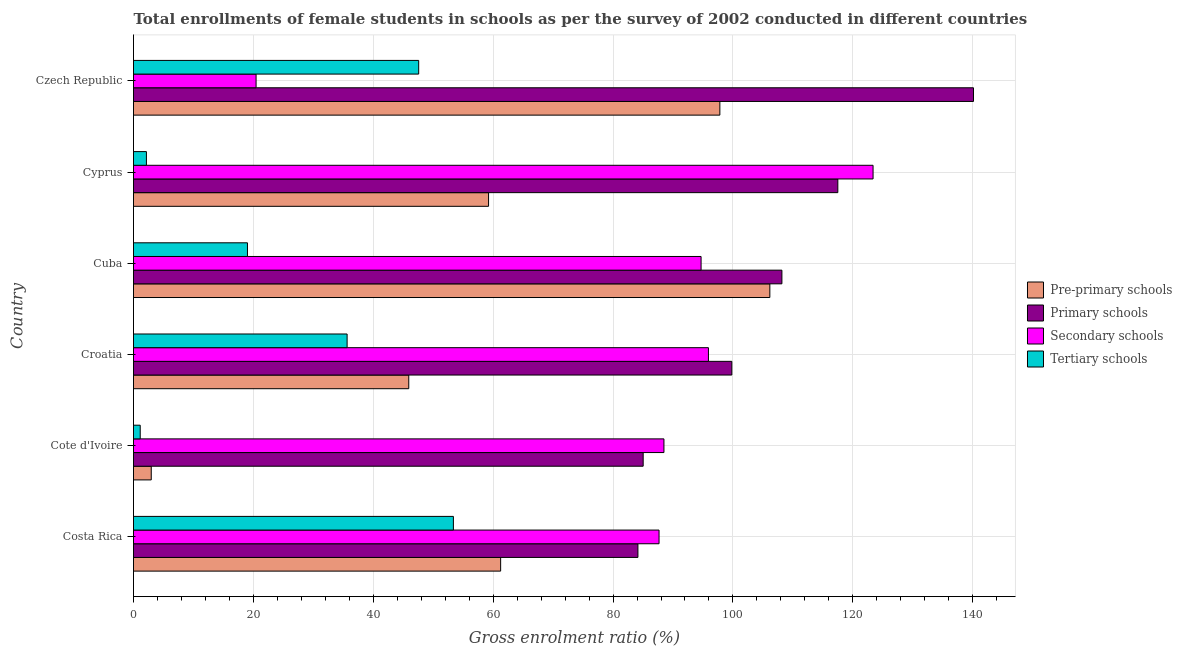How many different coloured bars are there?
Ensure brevity in your answer.  4. How many groups of bars are there?
Offer a very short reply. 6. Are the number of bars per tick equal to the number of legend labels?
Provide a succinct answer. Yes. In how many cases, is the number of bars for a given country not equal to the number of legend labels?
Your answer should be compact. 0. What is the gross enrolment ratio(female) in secondary schools in Croatia?
Give a very brief answer. 95.91. Across all countries, what is the maximum gross enrolment ratio(female) in primary schools?
Keep it short and to the point. 140.13. Across all countries, what is the minimum gross enrolment ratio(female) in secondary schools?
Ensure brevity in your answer.  20.45. In which country was the gross enrolment ratio(female) in pre-primary schools maximum?
Offer a terse response. Cuba. In which country was the gross enrolment ratio(female) in tertiary schools minimum?
Give a very brief answer. Cote d'Ivoire. What is the total gross enrolment ratio(female) in secondary schools in the graph?
Your response must be concise. 510.58. What is the difference between the gross enrolment ratio(female) in secondary schools in Croatia and that in Cyprus?
Give a very brief answer. -27.46. What is the difference between the gross enrolment ratio(female) in primary schools in Czech Republic and the gross enrolment ratio(female) in tertiary schools in Cote d'Ivoire?
Offer a terse response. 139.01. What is the average gross enrolment ratio(female) in secondary schools per country?
Make the answer very short. 85.1. What is the difference between the gross enrolment ratio(female) in primary schools and gross enrolment ratio(female) in secondary schools in Croatia?
Your answer should be very brief. 3.9. What is the ratio of the gross enrolment ratio(female) in primary schools in Costa Rica to that in Cuba?
Give a very brief answer. 0.78. Is the gross enrolment ratio(female) in secondary schools in Cote d'Ivoire less than that in Czech Republic?
Make the answer very short. No. Is the difference between the gross enrolment ratio(female) in primary schools in Cuba and Cyprus greater than the difference between the gross enrolment ratio(female) in tertiary schools in Cuba and Cyprus?
Give a very brief answer. No. What is the difference between the highest and the second highest gross enrolment ratio(female) in pre-primary schools?
Your answer should be compact. 8.34. What is the difference between the highest and the lowest gross enrolment ratio(female) in pre-primary schools?
Make the answer very short. 103.19. Is the sum of the gross enrolment ratio(female) in pre-primary schools in Costa Rica and Czech Republic greater than the maximum gross enrolment ratio(female) in primary schools across all countries?
Offer a very short reply. Yes. What does the 2nd bar from the top in Cote d'Ivoire represents?
Ensure brevity in your answer.  Secondary schools. What does the 3rd bar from the bottom in Croatia represents?
Provide a succinct answer. Secondary schools. Is it the case that in every country, the sum of the gross enrolment ratio(female) in pre-primary schools and gross enrolment ratio(female) in primary schools is greater than the gross enrolment ratio(female) in secondary schools?
Offer a very short reply. No. How many bars are there?
Give a very brief answer. 24. Are all the bars in the graph horizontal?
Your answer should be compact. Yes. How many countries are there in the graph?
Your answer should be very brief. 6. Are the values on the major ticks of X-axis written in scientific E-notation?
Offer a terse response. No. Does the graph contain grids?
Ensure brevity in your answer.  Yes. How are the legend labels stacked?
Provide a short and direct response. Vertical. What is the title of the graph?
Give a very brief answer. Total enrollments of female students in schools as per the survey of 2002 conducted in different countries. What is the Gross enrolment ratio (%) in Pre-primary schools in Costa Rica?
Make the answer very short. 61.25. What is the Gross enrolment ratio (%) of Primary schools in Costa Rica?
Keep it short and to the point. 84.15. What is the Gross enrolment ratio (%) of Secondary schools in Costa Rica?
Offer a terse response. 87.67. What is the Gross enrolment ratio (%) in Tertiary schools in Costa Rica?
Ensure brevity in your answer.  53.36. What is the Gross enrolment ratio (%) of Pre-primary schools in Cote d'Ivoire?
Your answer should be very brief. 2.96. What is the Gross enrolment ratio (%) of Primary schools in Cote d'Ivoire?
Make the answer very short. 85.03. What is the Gross enrolment ratio (%) in Secondary schools in Cote d'Ivoire?
Ensure brevity in your answer.  88.49. What is the Gross enrolment ratio (%) of Tertiary schools in Cote d'Ivoire?
Your response must be concise. 1.12. What is the Gross enrolment ratio (%) of Pre-primary schools in Croatia?
Your answer should be compact. 45.92. What is the Gross enrolment ratio (%) in Primary schools in Croatia?
Provide a short and direct response. 99.81. What is the Gross enrolment ratio (%) in Secondary schools in Croatia?
Offer a terse response. 95.91. What is the Gross enrolment ratio (%) in Tertiary schools in Croatia?
Your answer should be compact. 35.63. What is the Gross enrolment ratio (%) of Pre-primary schools in Cuba?
Your response must be concise. 106.15. What is the Gross enrolment ratio (%) in Primary schools in Cuba?
Give a very brief answer. 108.17. What is the Gross enrolment ratio (%) of Secondary schools in Cuba?
Keep it short and to the point. 94.68. What is the Gross enrolment ratio (%) in Tertiary schools in Cuba?
Your answer should be very brief. 19.01. What is the Gross enrolment ratio (%) in Pre-primary schools in Cyprus?
Offer a very short reply. 59.23. What is the Gross enrolment ratio (%) in Primary schools in Cyprus?
Ensure brevity in your answer.  117.5. What is the Gross enrolment ratio (%) in Secondary schools in Cyprus?
Provide a succinct answer. 123.38. What is the Gross enrolment ratio (%) of Tertiary schools in Cyprus?
Your answer should be compact. 2.16. What is the Gross enrolment ratio (%) of Pre-primary schools in Czech Republic?
Your response must be concise. 97.82. What is the Gross enrolment ratio (%) of Primary schools in Czech Republic?
Your response must be concise. 140.13. What is the Gross enrolment ratio (%) in Secondary schools in Czech Republic?
Your answer should be very brief. 20.45. What is the Gross enrolment ratio (%) of Tertiary schools in Czech Republic?
Keep it short and to the point. 47.57. Across all countries, what is the maximum Gross enrolment ratio (%) in Pre-primary schools?
Keep it short and to the point. 106.15. Across all countries, what is the maximum Gross enrolment ratio (%) in Primary schools?
Your response must be concise. 140.13. Across all countries, what is the maximum Gross enrolment ratio (%) of Secondary schools?
Your answer should be compact. 123.38. Across all countries, what is the maximum Gross enrolment ratio (%) of Tertiary schools?
Your answer should be very brief. 53.36. Across all countries, what is the minimum Gross enrolment ratio (%) in Pre-primary schools?
Offer a very short reply. 2.96. Across all countries, what is the minimum Gross enrolment ratio (%) in Primary schools?
Offer a terse response. 84.15. Across all countries, what is the minimum Gross enrolment ratio (%) in Secondary schools?
Give a very brief answer. 20.45. Across all countries, what is the minimum Gross enrolment ratio (%) in Tertiary schools?
Give a very brief answer. 1.12. What is the total Gross enrolment ratio (%) of Pre-primary schools in the graph?
Your answer should be compact. 373.33. What is the total Gross enrolment ratio (%) in Primary schools in the graph?
Your answer should be very brief. 634.78. What is the total Gross enrolment ratio (%) in Secondary schools in the graph?
Offer a very short reply. 510.58. What is the total Gross enrolment ratio (%) of Tertiary schools in the graph?
Your answer should be compact. 158.86. What is the difference between the Gross enrolment ratio (%) in Pre-primary schools in Costa Rica and that in Cote d'Ivoire?
Give a very brief answer. 58.29. What is the difference between the Gross enrolment ratio (%) in Primary schools in Costa Rica and that in Cote d'Ivoire?
Your answer should be very brief. -0.88. What is the difference between the Gross enrolment ratio (%) in Secondary schools in Costa Rica and that in Cote d'Ivoire?
Provide a short and direct response. -0.82. What is the difference between the Gross enrolment ratio (%) in Tertiary schools in Costa Rica and that in Cote d'Ivoire?
Ensure brevity in your answer.  52.24. What is the difference between the Gross enrolment ratio (%) in Pre-primary schools in Costa Rica and that in Croatia?
Your response must be concise. 15.33. What is the difference between the Gross enrolment ratio (%) of Primary schools in Costa Rica and that in Croatia?
Your response must be concise. -15.67. What is the difference between the Gross enrolment ratio (%) in Secondary schools in Costa Rica and that in Croatia?
Your response must be concise. -8.24. What is the difference between the Gross enrolment ratio (%) of Tertiary schools in Costa Rica and that in Croatia?
Your response must be concise. 17.73. What is the difference between the Gross enrolment ratio (%) in Pre-primary schools in Costa Rica and that in Cuba?
Give a very brief answer. -44.91. What is the difference between the Gross enrolment ratio (%) in Primary schools in Costa Rica and that in Cuba?
Give a very brief answer. -24.02. What is the difference between the Gross enrolment ratio (%) in Secondary schools in Costa Rica and that in Cuba?
Ensure brevity in your answer.  -7.01. What is the difference between the Gross enrolment ratio (%) of Tertiary schools in Costa Rica and that in Cuba?
Offer a terse response. 34.35. What is the difference between the Gross enrolment ratio (%) in Pre-primary schools in Costa Rica and that in Cyprus?
Offer a terse response. 2.01. What is the difference between the Gross enrolment ratio (%) of Primary schools in Costa Rica and that in Cyprus?
Provide a succinct answer. -33.35. What is the difference between the Gross enrolment ratio (%) in Secondary schools in Costa Rica and that in Cyprus?
Keep it short and to the point. -35.7. What is the difference between the Gross enrolment ratio (%) in Tertiary schools in Costa Rica and that in Cyprus?
Offer a very short reply. 51.21. What is the difference between the Gross enrolment ratio (%) in Pre-primary schools in Costa Rica and that in Czech Republic?
Give a very brief answer. -36.57. What is the difference between the Gross enrolment ratio (%) of Primary schools in Costa Rica and that in Czech Republic?
Your answer should be very brief. -55.98. What is the difference between the Gross enrolment ratio (%) of Secondary schools in Costa Rica and that in Czech Republic?
Keep it short and to the point. 67.23. What is the difference between the Gross enrolment ratio (%) of Tertiary schools in Costa Rica and that in Czech Republic?
Offer a terse response. 5.79. What is the difference between the Gross enrolment ratio (%) of Pre-primary schools in Cote d'Ivoire and that in Croatia?
Give a very brief answer. -42.96. What is the difference between the Gross enrolment ratio (%) of Primary schools in Cote d'Ivoire and that in Croatia?
Offer a very short reply. -14.79. What is the difference between the Gross enrolment ratio (%) of Secondary schools in Cote d'Ivoire and that in Croatia?
Ensure brevity in your answer.  -7.43. What is the difference between the Gross enrolment ratio (%) of Tertiary schools in Cote d'Ivoire and that in Croatia?
Offer a very short reply. -34.51. What is the difference between the Gross enrolment ratio (%) in Pre-primary schools in Cote d'Ivoire and that in Cuba?
Provide a short and direct response. -103.19. What is the difference between the Gross enrolment ratio (%) of Primary schools in Cote d'Ivoire and that in Cuba?
Your response must be concise. -23.14. What is the difference between the Gross enrolment ratio (%) in Secondary schools in Cote d'Ivoire and that in Cuba?
Offer a very short reply. -6.2. What is the difference between the Gross enrolment ratio (%) in Tertiary schools in Cote d'Ivoire and that in Cuba?
Ensure brevity in your answer.  -17.89. What is the difference between the Gross enrolment ratio (%) of Pre-primary schools in Cote d'Ivoire and that in Cyprus?
Your response must be concise. -56.27. What is the difference between the Gross enrolment ratio (%) of Primary schools in Cote d'Ivoire and that in Cyprus?
Offer a very short reply. -32.47. What is the difference between the Gross enrolment ratio (%) of Secondary schools in Cote d'Ivoire and that in Cyprus?
Your response must be concise. -34.89. What is the difference between the Gross enrolment ratio (%) in Tertiary schools in Cote d'Ivoire and that in Cyprus?
Keep it short and to the point. -1.03. What is the difference between the Gross enrolment ratio (%) in Pre-primary schools in Cote d'Ivoire and that in Czech Republic?
Ensure brevity in your answer.  -94.86. What is the difference between the Gross enrolment ratio (%) in Primary schools in Cote d'Ivoire and that in Czech Republic?
Your answer should be very brief. -55.1. What is the difference between the Gross enrolment ratio (%) in Secondary schools in Cote d'Ivoire and that in Czech Republic?
Keep it short and to the point. 68.04. What is the difference between the Gross enrolment ratio (%) in Tertiary schools in Cote d'Ivoire and that in Czech Republic?
Your response must be concise. -46.45. What is the difference between the Gross enrolment ratio (%) in Pre-primary schools in Croatia and that in Cuba?
Offer a very short reply. -60.24. What is the difference between the Gross enrolment ratio (%) of Primary schools in Croatia and that in Cuba?
Ensure brevity in your answer.  -8.35. What is the difference between the Gross enrolment ratio (%) in Secondary schools in Croatia and that in Cuba?
Your response must be concise. 1.23. What is the difference between the Gross enrolment ratio (%) of Tertiary schools in Croatia and that in Cuba?
Provide a short and direct response. 16.62. What is the difference between the Gross enrolment ratio (%) of Pre-primary schools in Croatia and that in Cyprus?
Your response must be concise. -13.31. What is the difference between the Gross enrolment ratio (%) in Primary schools in Croatia and that in Cyprus?
Give a very brief answer. -17.68. What is the difference between the Gross enrolment ratio (%) of Secondary schools in Croatia and that in Cyprus?
Provide a short and direct response. -27.46. What is the difference between the Gross enrolment ratio (%) of Tertiary schools in Croatia and that in Cyprus?
Offer a very short reply. 33.48. What is the difference between the Gross enrolment ratio (%) of Pre-primary schools in Croatia and that in Czech Republic?
Provide a short and direct response. -51.9. What is the difference between the Gross enrolment ratio (%) of Primary schools in Croatia and that in Czech Republic?
Give a very brief answer. -40.31. What is the difference between the Gross enrolment ratio (%) in Secondary schools in Croatia and that in Czech Republic?
Keep it short and to the point. 75.47. What is the difference between the Gross enrolment ratio (%) in Tertiary schools in Croatia and that in Czech Republic?
Offer a terse response. -11.94. What is the difference between the Gross enrolment ratio (%) in Pre-primary schools in Cuba and that in Cyprus?
Keep it short and to the point. 46.92. What is the difference between the Gross enrolment ratio (%) of Primary schools in Cuba and that in Cyprus?
Your answer should be very brief. -9.33. What is the difference between the Gross enrolment ratio (%) in Secondary schools in Cuba and that in Cyprus?
Keep it short and to the point. -28.69. What is the difference between the Gross enrolment ratio (%) in Tertiary schools in Cuba and that in Cyprus?
Provide a succinct answer. 16.86. What is the difference between the Gross enrolment ratio (%) in Pre-primary schools in Cuba and that in Czech Republic?
Offer a very short reply. 8.34. What is the difference between the Gross enrolment ratio (%) in Primary schools in Cuba and that in Czech Republic?
Provide a succinct answer. -31.96. What is the difference between the Gross enrolment ratio (%) in Secondary schools in Cuba and that in Czech Republic?
Keep it short and to the point. 74.24. What is the difference between the Gross enrolment ratio (%) in Tertiary schools in Cuba and that in Czech Republic?
Your response must be concise. -28.56. What is the difference between the Gross enrolment ratio (%) in Pre-primary schools in Cyprus and that in Czech Republic?
Your response must be concise. -38.58. What is the difference between the Gross enrolment ratio (%) of Primary schools in Cyprus and that in Czech Republic?
Your answer should be very brief. -22.63. What is the difference between the Gross enrolment ratio (%) in Secondary schools in Cyprus and that in Czech Republic?
Your answer should be compact. 102.93. What is the difference between the Gross enrolment ratio (%) of Tertiary schools in Cyprus and that in Czech Republic?
Make the answer very short. -45.42. What is the difference between the Gross enrolment ratio (%) of Pre-primary schools in Costa Rica and the Gross enrolment ratio (%) of Primary schools in Cote d'Ivoire?
Ensure brevity in your answer.  -23.78. What is the difference between the Gross enrolment ratio (%) of Pre-primary schools in Costa Rica and the Gross enrolment ratio (%) of Secondary schools in Cote d'Ivoire?
Give a very brief answer. -27.24. What is the difference between the Gross enrolment ratio (%) of Pre-primary schools in Costa Rica and the Gross enrolment ratio (%) of Tertiary schools in Cote d'Ivoire?
Your answer should be compact. 60.12. What is the difference between the Gross enrolment ratio (%) in Primary schools in Costa Rica and the Gross enrolment ratio (%) in Secondary schools in Cote d'Ivoire?
Give a very brief answer. -4.34. What is the difference between the Gross enrolment ratio (%) of Primary schools in Costa Rica and the Gross enrolment ratio (%) of Tertiary schools in Cote d'Ivoire?
Your answer should be compact. 83.03. What is the difference between the Gross enrolment ratio (%) in Secondary schools in Costa Rica and the Gross enrolment ratio (%) in Tertiary schools in Cote d'Ivoire?
Your answer should be very brief. 86.55. What is the difference between the Gross enrolment ratio (%) of Pre-primary schools in Costa Rica and the Gross enrolment ratio (%) of Primary schools in Croatia?
Your answer should be compact. -38.57. What is the difference between the Gross enrolment ratio (%) in Pre-primary schools in Costa Rica and the Gross enrolment ratio (%) in Secondary schools in Croatia?
Provide a succinct answer. -34.67. What is the difference between the Gross enrolment ratio (%) of Pre-primary schools in Costa Rica and the Gross enrolment ratio (%) of Tertiary schools in Croatia?
Your answer should be compact. 25.61. What is the difference between the Gross enrolment ratio (%) of Primary schools in Costa Rica and the Gross enrolment ratio (%) of Secondary schools in Croatia?
Your response must be concise. -11.76. What is the difference between the Gross enrolment ratio (%) of Primary schools in Costa Rica and the Gross enrolment ratio (%) of Tertiary schools in Croatia?
Keep it short and to the point. 48.51. What is the difference between the Gross enrolment ratio (%) in Secondary schools in Costa Rica and the Gross enrolment ratio (%) in Tertiary schools in Croatia?
Provide a succinct answer. 52.04. What is the difference between the Gross enrolment ratio (%) in Pre-primary schools in Costa Rica and the Gross enrolment ratio (%) in Primary schools in Cuba?
Make the answer very short. -46.92. What is the difference between the Gross enrolment ratio (%) of Pre-primary schools in Costa Rica and the Gross enrolment ratio (%) of Secondary schools in Cuba?
Provide a succinct answer. -33.44. What is the difference between the Gross enrolment ratio (%) in Pre-primary schools in Costa Rica and the Gross enrolment ratio (%) in Tertiary schools in Cuba?
Provide a succinct answer. 42.23. What is the difference between the Gross enrolment ratio (%) of Primary schools in Costa Rica and the Gross enrolment ratio (%) of Secondary schools in Cuba?
Give a very brief answer. -10.54. What is the difference between the Gross enrolment ratio (%) in Primary schools in Costa Rica and the Gross enrolment ratio (%) in Tertiary schools in Cuba?
Your answer should be compact. 65.14. What is the difference between the Gross enrolment ratio (%) of Secondary schools in Costa Rica and the Gross enrolment ratio (%) of Tertiary schools in Cuba?
Provide a succinct answer. 68.66. What is the difference between the Gross enrolment ratio (%) of Pre-primary schools in Costa Rica and the Gross enrolment ratio (%) of Primary schools in Cyprus?
Offer a very short reply. -56.25. What is the difference between the Gross enrolment ratio (%) in Pre-primary schools in Costa Rica and the Gross enrolment ratio (%) in Secondary schools in Cyprus?
Keep it short and to the point. -62.13. What is the difference between the Gross enrolment ratio (%) in Pre-primary schools in Costa Rica and the Gross enrolment ratio (%) in Tertiary schools in Cyprus?
Provide a short and direct response. 59.09. What is the difference between the Gross enrolment ratio (%) of Primary schools in Costa Rica and the Gross enrolment ratio (%) of Secondary schools in Cyprus?
Ensure brevity in your answer.  -39.23. What is the difference between the Gross enrolment ratio (%) of Primary schools in Costa Rica and the Gross enrolment ratio (%) of Tertiary schools in Cyprus?
Provide a succinct answer. 81.99. What is the difference between the Gross enrolment ratio (%) of Secondary schools in Costa Rica and the Gross enrolment ratio (%) of Tertiary schools in Cyprus?
Provide a succinct answer. 85.52. What is the difference between the Gross enrolment ratio (%) of Pre-primary schools in Costa Rica and the Gross enrolment ratio (%) of Primary schools in Czech Republic?
Offer a very short reply. -78.88. What is the difference between the Gross enrolment ratio (%) in Pre-primary schools in Costa Rica and the Gross enrolment ratio (%) in Secondary schools in Czech Republic?
Your response must be concise. 40.8. What is the difference between the Gross enrolment ratio (%) of Pre-primary schools in Costa Rica and the Gross enrolment ratio (%) of Tertiary schools in Czech Republic?
Ensure brevity in your answer.  13.67. What is the difference between the Gross enrolment ratio (%) in Primary schools in Costa Rica and the Gross enrolment ratio (%) in Secondary schools in Czech Republic?
Your answer should be compact. 63.7. What is the difference between the Gross enrolment ratio (%) in Primary schools in Costa Rica and the Gross enrolment ratio (%) in Tertiary schools in Czech Republic?
Give a very brief answer. 36.57. What is the difference between the Gross enrolment ratio (%) in Secondary schools in Costa Rica and the Gross enrolment ratio (%) in Tertiary schools in Czech Republic?
Provide a short and direct response. 40.1. What is the difference between the Gross enrolment ratio (%) in Pre-primary schools in Cote d'Ivoire and the Gross enrolment ratio (%) in Primary schools in Croatia?
Provide a short and direct response. -96.85. What is the difference between the Gross enrolment ratio (%) in Pre-primary schools in Cote d'Ivoire and the Gross enrolment ratio (%) in Secondary schools in Croatia?
Your response must be concise. -92.95. What is the difference between the Gross enrolment ratio (%) of Pre-primary schools in Cote d'Ivoire and the Gross enrolment ratio (%) of Tertiary schools in Croatia?
Keep it short and to the point. -32.67. What is the difference between the Gross enrolment ratio (%) in Primary schools in Cote d'Ivoire and the Gross enrolment ratio (%) in Secondary schools in Croatia?
Offer a very short reply. -10.89. What is the difference between the Gross enrolment ratio (%) of Primary schools in Cote d'Ivoire and the Gross enrolment ratio (%) of Tertiary schools in Croatia?
Your answer should be compact. 49.39. What is the difference between the Gross enrolment ratio (%) of Secondary schools in Cote d'Ivoire and the Gross enrolment ratio (%) of Tertiary schools in Croatia?
Provide a short and direct response. 52.85. What is the difference between the Gross enrolment ratio (%) of Pre-primary schools in Cote d'Ivoire and the Gross enrolment ratio (%) of Primary schools in Cuba?
Provide a short and direct response. -105.21. What is the difference between the Gross enrolment ratio (%) of Pre-primary schools in Cote d'Ivoire and the Gross enrolment ratio (%) of Secondary schools in Cuba?
Keep it short and to the point. -91.72. What is the difference between the Gross enrolment ratio (%) in Pre-primary schools in Cote d'Ivoire and the Gross enrolment ratio (%) in Tertiary schools in Cuba?
Keep it short and to the point. -16.05. What is the difference between the Gross enrolment ratio (%) in Primary schools in Cote d'Ivoire and the Gross enrolment ratio (%) in Secondary schools in Cuba?
Your response must be concise. -9.66. What is the difference between the Gross enrolment ratio (%) in Primary schools in Cote d'Ivoire and the Gross enrolment ratio (%) in Tertiary schools in Cuba?
Provide a short and direct response. 66.01. What is the difference between the Gross enrolment ratio (%) in Secondary schools in Cote d'Ivoire and the Gross enrolment ratio (%) in Tertiary schools in Cuba?
Give a very brief answer. 69.48. What is the difference between the Gross enrolment ratio (%) in Pre-primary schools in Cote d'Ivoire and the Gross enrolment ratio (%) in Primary schools in Cyprus?
Offer a terse response. -114.54. What is the difference between the Gross enrolment ratio (%) in Pre-primary schools in Cote d'Ivoire and the Gross enrolment ratio (%) in Secondary schools in Cyprus?
Your response must be concise. -120.42. What is the difference between the Gross enrolment ratio (%) in Pre-primary schools in Cote d'Ivoire and the Gross enrolment ratio (%) in Tertiary schools in Cyprus?
Give a very brief answer. 0.81. What is the difference between the Gross enrolment ratio (%) in Primary schools in Cote d'Ivoire and the Gross enrolment ratio (%) in Secondary schools in Cyprus?
Your response must be concise. -38.35. What is the difference between the Gross enrolment ratio (%) in Primary schools in Cote d'Ivoire and the Gross enrolment ratio (%) in Tertiary schools in Cyprus?
Ensure brevity in your answer.  82.87. What is the difference between the Gross enrolment ratio (%) of Secondary schools in Cote d'Ivoire and the Gross enrolment ratio (%) of Tertiary schools in Cyprus?
Provide a succinct answer. 86.33. What is the difference between the Gross enrolment ratio (%) of Pre-primary schools in Cote d'Ivoire and the Gross enrolment ratio (%) of Primary schools in Czech Republic?
Make the answer very short. -137.17. What is the difference between the Gross enrolment ratio (%) of Pre-primary schools in Cote d'Ivoire and the Gross enrolment ratio (%) of Secondary schools in Czech Republic?
Make the answer very short. -17.49. What is the difference between the Gross enrolment ratio (%) in Pre-primary schools in Cote d'Ivoire and the Gross enrolment ratio (%) in Tertiary schools in Czech Republic?
Make the answer very short. -44.61. What is the difference between the Gross enrolment ratio (%) of Primary schools in Cote d'Ivoire and the Gross enrolment ratio (%) of Secondary schools in Czech Republic?
Your answer should be compact. 64.58. What is the difference between the Gross enrolment ratio (%) of Primary schools in Cote d'Ivoire and the Gross enrolment ratio (%) of Tertiary schools in Czech Republic?
Offer a terse response. 37.45. What is the difference between the Gross enrolment ratio (%) in Secondary schools in Cote d'Ivoire and the Gross enrolment ratio (%) in Tertiary schools in Czech Republic?
Make the answer very short. 40.91. What is the difference between the Gross enrolment ratio (%) of Pre-primary schools in Croatia and the Gross enrolment ratio (%) of Primary schools in Cuba?
Ensure brevity in your answer.  -62.25. What is the difference between the Gross enrolment ratio (%) in Pre-primary schools in Croatia and the Gross enrolment ratio (%) in Secondary schools in Cuba?
Ensure brevity in your answer.  -48.77. What is the difference between the Gross enrolment ratio (%) in Pre-primary schools in Croatia and the Gross enrolment ratio (%) in Tertiary schools in Cuba?
Provide a short and direct response. 26.91. What is the difference between the Gross enrolment ratio (%) in Primary schools in Croatia and the Gross enrolment ratio (%) in Secondary schools in Cuba?
Your answer should be very brief. 5.13. What is the difference between the Gross enrolment ratio (%) in Primary schools in Croatia and the Gross enrolment ratio (%) in Tertiary schools in Cuba?
Provide a succinct answer. 80.8. What is the difference between the Gross enrolment ratio (%) of Secondary schools in Croatia and the Gross enrolment ratio (%) of Tertiary schools in Cuba?
Provide a succinct answer. 76.9. What is the difference between the Gross enrolment ratio (%) of Pre-primary schools in Croatia and the Gross enrolment ratio (%) of Primary schools in Cyprus?
Provide a short and direct response. -71.58. What is the difference between the Gross enrolment ratio (%) of Pre-primary schools in Croatia and the Gross enrolment ratio (%) of Secondary schools in Cyprus?
Your answer should be very brief. -77.46. What is the difference between the Gross enrolment ratio (%) in Pre-primary schools in Croatia and the Gross enrolment ratio (%) in Tertiary schools in Cyprus?
Your response must be concise. 43.76. What is the difference between the Gross enrolment ratio (%) in Primary schools in Croatia and the Gross enrolment ratio (%) in Secondary schools in Cyprus?
Give a very brief answer. -23.56. What is the difference between the Gross enrolment ratio (%) in Primary schools in Croatia and the Gross enrolment ratio (%) in Tertiary schools in Cyprus?
Offer a terse response. 97.66. What is the difference between the Gross enrolment ratio (%) in Secondary schools in Croatia and the Gross enrolment ratio (%) in Tertiary schools in Cyprus?
Your answer should be compact. 93.76. What is the difference between the Gross enrolment ratio (%) of Pre-primary schools in Croatia and the Gross enrolment ratio (%) of Primary schools in Czech Republic?
Provide a succinct answer. -94.21. What is the difference between the Gross enrolment ratio (%) in Pre-primary schools in Croatia and the Gross enrolment ratio (%) in Secondary schools in Czech Republic?
Ensure brevity in your answer.  25.47. What is the difference between the Gross enrolment ratio (%) of Pre-primary schools in Croatia and the Gross enrolment ratio (%) of Tertiary schools in Czech Republic?
Give a very brief answer. -1.66. What is the difference between the Gross enrolment ratio (%) in Primary schools in Croatia and the Gross enrolment ratio (%) in Secondary schools in Czech Republic?
Your response must be concise. 79.37. What is the difference between the Gross enrolment ratio (%) in Primary schools in Croatia and the Gross enrolment ratio (%) in Tertiary schools in Czech Republic?
Your answer should be very brief. 52.24. What is the difference between the Gross enrolment ratio (%) in Secondary schools in Croatia and the Gross enrolment ratio (%) in Tertiary schools in Czech Republic?
Offer a very short reply. 48.34. What is the difference between the Gross enrolment ratio (%) of Pre-primary schools in Cuba and the Gross enrolment ratio (%) of Primary schools in Cyprus?
Ensure brevity in your answer.  -11.34. What is the difference between the Gross enrolment ratio (%) in Pre-primary schools in Cuba and the Gross enrolment ratio (%) in Secondary schools in Cyprus?
Your answer should be very brief. -17.22. What is the difference between the Gross enrolment ratio (%) in Pre-primary schools in Cuba and the Gross enrolment ratio (%) in Tertiary schools in Cyprus?
Make the answer very short. 104. What is the difference between the Gross enrolment ratio (%) of Primary schools in Cuba and the Gross enrolment ratio (%) of Secondary schools in Cyprus?
Keep it short and to the point. -15.21. What is the difference between the Gross enrolment ratio (%) of Primary schools in Cuba and the Gross enrolment ratio (%) of Tertiary schools in Cyprus?
Ensure brevity in your answer.  106.01. What is the difference between the Gross enrolment ratio (%) in Secondary schools in Cuba and the Gross enrolment ratio (%) in Tertiary schools in Cyprus?
Offer a very short reply. 92.53. What is the difference between the Gross enrolment ratio (%) of Pre-primary schools in Cuba and the Gross enrolment ratio (%) of Primary schools in Czech Republic?
Make the answer very short. -33.97. What is the difference between the Gross enrolment ratio (%) in Pre-primary schools in Cuba and the Gross enrolment ratio (%) in Secondary schools in Czech Republic?
Provide a short and direct response. 85.71. What is the difference between the Gross enrolment ratio (%) in Pre-primary schools in Cuba and the Gross enrolment ratio (%) in Tertiary schools in Czech Republic?
Your response must be concise. 58.58. What is the difference between the Gross enrolment ratio (%) of Primary schools in Cuba and the Gross enrolment ratio (%) of Secondary schools in Czech Republic?
Provide a short and direct response. 87.72. What is the difference between the Gross enrolment ratio (%) in Primary schools in Cuba and the Gross enrolment ratio (%) in Tertiary schools in Czech Republic?
Keep it short and to the point. 60.59. What is the difference between the Gross enrolment ratio (%) of Secondary schools in Cuba and the Gross enrolment ratio (%) of Tertiary schools in Czech Republic?
Ensure brevity in your answer.  47.11. What is the difference between the Gross enrolment ratio (%) of Pre-primary schools in Cyprus and the Gross enrolment ratio (%) of Primary schools in Czech Republic?
Offer a very short reply. -80.89. What is the difference between the Gross enrolment ratio (%) of Pre-primary schools in Cyprus and the Gross enrolment ratio (%) of Secondary schools in Czech Republic?
Offer a very short reply. 38.78. What is the difference between the Gross enrolment ratio (%) in Pre-primary schools in Cyprus and the Gross enrolment ratio (%) in Tertiary schools in Czech Republic?
Ensure brevity in your answer.  11.66. What is the difference between the Gross enrolment ratio (%) of Primary schools in Cyprus and the Gross enrolment ratio (%) of Secondary schools in Czech Republic?
Provide a short and direct response. 97.05. What is the difference between the Gross enrolment ratio (%) in Primary schools in Cyprus and the Gross enrolment ratio (%) in Tertiary schools in Czech Republic?
Give a very brief answer. 69.92. What is the difference between the Gross enrolment ratio (%) in Secondary schools in Cyprus and the Gross enrolment ratio (%) in Tertiary schools in Czech Republic?
Ensure brevity in your answer.  75.8. What is the average Gross enrolment ratio (%) of Pre-primary schools per country?
Offer a very short reply. 62.22. What is the average Gross enrolment ratio (%) of Primary schools per country?
Your response must be concise. 105.8. What is the average Gross enrolment ratio (%) in Secondary schools per country?
Offer a very short reply. 85.1. What is the average Gross enrolment ratio (%) of Tertiary schools per country?
Your answer should be very brief. 26.48. What is the difference between the Gross enrolment ratio (%) in Pre-primary schools and Gross enrolment ratio (%) in Primary schools in Costa Rica?
Ensure brevity in your answer.  -22.9. What is the difference between the Gross enrolment ratio (%) of Pre-primary schools and Gross enrolment ratio (%) of Secondary schools in Costa Rica?
Your response must be concise. -26.43. What is the difference between the Gross enrolment ratio (%) of Pre-primary schools and Gross enrolment ratio (%) of Tertiary schools in Costa Rica?
Keep it short and to the point. 7.88. What is the difference between the Gross enrolment ratio (%) of Primary schools and Gross enrolment ratio (%) of Secondary schools in Costa Rica?
Keep it short and to the point. -3.52. What is the difference between the Gross enrolment ratio (%) in Primary schools and Gross enrolment ratio (%) in Tertiary schools in Costa Rica?
Your answer should be compact. 30.78. What is the difference between the Gross enrolment ratio (%) in Secondary schools and Gross enrolment ratio (%) in Tertiary schools in Costa Rica?
Your answer should be compact. 34.31. What is the difference between the Gross enrolment ratio (%) in Pre-primary schools and Gross enrolment ratio (%) in Primary schools in Cote d'Ivoire?
Your response must be concise. -82.06. What is the difference between the Gross enrolment ratio (%) in Pre-primary schools and Gross enrolment ratio (%) in Secondary schools in Cote d'Ivoire?
Offer a terse response. -85.53. What is the difference between the Gross enrolment ratio (%) of Pre-primary schools and Gross enrolment ratio (%) of Tertiary schools in Cote d'Ivoire?
Provide a succinct answer. 1.84. What is the difference between the Gross enrolment ratio (%) of Primary schools and Gross enrolment ratio (%) of Secondary schools in Cote d'Ivoire?
Provide a short and direct response. -3.46. What is the difference between the Gross enrolment ratio (%) in Primary schools and Gross enrolment ratio (%) in Tertiary schools in Cote d'Ivoire?
Ensure brevity in your answer.  83.9. What is the difference between the Gross enrolment ratio (%) of Secondary schools and Gross enrolment ratio (%) of Tertiary schools in Cote d'Ivoire?
Offer a very short reply. 87.37. What is the difference between the Gross enrolment ratio (%) in Pre-primary schools and Gross enrolment ratio (%) in Primary schools in Croatia?
Make the answer very short. -53.89. What is the difference between the Gross enrolment ratio (%) in Pre-primary schools and Gross enrolment ratio (%) in Secondary schools in Croatia?
Provide a succinct answer. -49.99. What is the difference between the Gross enrolment ratio (%) of Pre-primary schools and Gross enrolment ratio (%) of Tertiary schools in Croatia?
Your response must be concise. 10.29. What is the difference between the Gross enrolment ratio (%) of Primary schools and Gross enrolment ratio (%) of Secondary schools in Croatia?
Your answer should be very brief. 3.9. What is the difference between the Gross enrolment ratio (%) of Primary schools and Gross enrolment ratio (%) of Tertiary schools in Croatia?
Give a very brief answer. 64.18. What is the difference between the Gross enrolment ratio (%) in Secondary schools and Gross enrolment ratio (%) in Tertiary schools in Croatia?
Your answer should be compact. 60.28. What is the difference between the Gross enrolment ratio (%) in Pre-primary schools and Gross enrolment ratio (%) in Primary schools in Cuba?
Your response must be concise. -2.01. What is the difference between the Gross enrolment ratio (%) in Pre-primary schools and Gross enrolment ratio (%) in Secondary schools in Cuba?
Give a very brief answer. 11.47. What is the difference between the Gross enrolment ratio (%) in Pre-primary schools and Gross enrolment ratio (%) in Tertiary schools in Cuba?
Your answer should be compact. 87.14. What is the difference between the Gross enrolment ratio (%) in Primary schools and Gross enrolment ratio (%) in Secondary schools in Cuba?
Ensure brevity in your answer.  13.48. What is the difference between the Gross enrolment ratio (%) in Primary schools and Gross enrolment ratio (%) in Tertiary schools in Cuba?
Your answer should be very brief. 89.16. What is the difference between the Gross enrolment ratio (%) of Secondary schools and Gross enrolment ratio (%) of Tertiary schools in Cuba?
Provide a short and direct response. 75.67. What is the difference between the Gross enrolment ratio (%) of Pre-primary schools and Gross enrolment ratio (%) of Primary schools in Cyprus?
Your answer should be very brief. -58.27. What is the difference between the Gross enrolment ratio (%) of Pre-primary schools and Gross enrolment ratio (%) of Secondary schools in Cyprus?
Keep it short and to the point. -64.14. What is the difference between the Gross enrolment ratio (%) of Pre-primary schools and Gross enrolment ratio (%) of Tertiary schools in Cyprus?
Provide a succinct answer. 57.08. What is the difference between the Gross enrolment ratio (%) in Primary schools and Gross enrolment ratio (%) in Secondary schools in Cyprus?
Provide a succinct answer. -5.88. What is the difference between the Gross enrolment ratio (%) in Primary schools and Gross enrolment ratio (%) in Tertiary schools in Cyprus?
Ensure brevity in your answer.  115.34. What is the difference between the Gross enrolment ratio (%) of Secondary schools and Gross enrolment ratio (%) of Tertiary schools in Cyprus?
Offer a terse response. 121.22. What is the difference between the Gross enrolment ratio (%) in Pre-primary schools and Gross enrolment ratio (%) in Primary schools in Czech Republic?
Give a very brief answer. -42.31. What is the difference between the Gross enrolment ratio (%) of Pre-primary schools and Gross enrolment ratio (%) of Secondary schools in Czech Republic?
Your answer should be very brief. 77.37. What is the difference between the Gross enrolment ratio (%) of Pre-primary schools and Gross enrolment ratio (%) of Tertiary schools in Czech Republic?
Provide a short and direct response. 50.24. What is the difference between the Gross enrolment ratio (%) of Primary schools and Gross enrolment ratio (%) of Secondary schools in Czech Republic?
Make the answer very short. 119.68. What is the difference between the Gross enrolment ratio (%) in Primary schools and Gross enrolment ratio (%) in Tertiary schools in Czech Republic?
Your answer should be compact. 92.55. What is the difference between the Gross enrolment ratio (%) in Secondary schools and Gross enrolment ratio (%) in Tertiary schools in Czech Republic?
Your answer should be very brief. -27.13. What is the ratio of the Gross enrolment ratio (%) of Pre-primary schools in Costa Rica to that in Cote d'Ivoire?
Offer a very short reply. 20.69. What is the ratio of the Gross enrolment ratio (%) in Secondary schools in Costa Rica to that in Cote d'Ivoire?
Your answer should be compact. 0.99. What is the ratio of the Gross enrolment ratio (%) in Tertiary schools in Costa Rica to that in Cote d'Ivoire?
Your answer should be compact. 47.6. What is the ratio of the Gross enrolment ratio (%) in Pre-primary schools in Costa Rica to that in Croatia?
Ensure brevity in your answer.  1.33. What is the ratio of the Gross enrolment ratio (%) of Primary schools in Costa Rica to that in Croatia?
Your answer should be very brief. 0.84. What is the ratio of the Gross enrolment ratio (%) in Secondary schools in Costa Rica to that in Croatia?
Offer a terse response. 0.91. What is the ratio of the Gross enrolment ratio (%) in Tertiary schools in Costa Rica to that in Croatia?
Offer a very short reply. 1.5. What is the ratio of the Gross enrolment ratio (%) of Pre-primary schools in Costa Rica to that in Cuba?
Keep it short and to the point. 0.58. What is the ratio of the Gross enrolment ratio (%) in Primary schools in Costa Rica to that in Cuba?
Ensure brevity in your answer.  0.78. What is the ratio of the Gross enrolment ratio (%) in Secondary schools in Costa Rica to that in Cuba?
Your response must be concise. 0.93. What is the ratio of the Gross enrolment ratio (%) in Tertiary schools in Costa Rica to that in Cuba?
Your answer should be compact. 2.81. What is the ratio of the Gross enrolment ratio (%) in Pre-primary schools in Costa Rica to that in Cyprus?
Ensure brevity in your answer.  1.03. What is the ratio of the Gross enrolment ratio (%) of Primary schools in Costa Rica to that in Cyprus?
Provide a succinct answer. 0.72. What is the ratio of the Gross enrolment ratio (%) of Secondary schools in Costa Rica to that in Cyprus?
Keep it short and to the point. 0.71. What is the ratio of the Gross enrolment ratio (%) in Tertiary schools in Costa Rica to that in Cyprus?
Keep it short and to the point. 24.76. What is the ratio of the Gross enrolment ratio (%) of Pre-primary schools in Costa Rica to that in Czech Republic?
Keep it short and to the point. 0.63. What is the ratio of the Gross enrolment ratio (%) of Primary schools in Costa Rica to that in Czech Republic?
Ensure brevity in your answer.  0.6. What is the ratio of the Gross enrolment ratio (%) in Secondary schools in Costa Rica to that in Czech Republic?
Your answer should be compact. 4.29. What is the ratio of the Gross enrolment ratio (%) of Tertiary schools in Costa Rica to that in Czech Republic?
Your answer should be compact. 1.12. What is the ratio of the Gross enrolment ratio (%) in Pre-primary schools in Cote d'Ivoire to that in Croatia?
Your answer should be compact. 0.06. What is the ratio of the Gross enrolment ratio (%) in Primary schools in Cote d'Ivoire to that in Croatia?
Your response must be concise. 0.85. What is the ratio of the Gross enrolment ratio (%) in Secondary schools in Cote d'Ivoire to that in Croatia?
Offer a very short reply. 0.92. What is the ratio of the Gross enrolment ratio (%) in Tertiary schools in Cote d'Ivoire to that in Croatia?
Ensure brevity in your answer.  0.03. What is the ratio of the Gross enrolment ratio (%) of Pre-primary schools in Cote d'Ivoire to that in Cuba?
Offer a very short reply. 0.03. What is the ratio of the Gross enrolment ratio (%) of Primary schools in Cote d'Ivoire to that in Cuba?
Ensure brevity in your answer.  0.79. What is the ratio of the Gross enrolment ratio (%) of Secondary schools in Cote d'Ivoire to that in Cuba?
Make the answer very short. 0.93. What is the ratio of the Gross enrolment ratio (%) of Tertiary schools in Cote d'Ivoire to that in Cuba?
Ensure brevity in your answer.  0.06. What is the ratio of the Gross enrolment ratio (%) of Primary schools in Cote d'Ivoire to that in Cyprus?
Provide a succinct answer. 0.72. What is the ratio of the Gross enrolment ratio (%) in Secondary schools in Cote d'Ivoire to that in Cyprus?
Ensure brevity in your answer.  0.72. What is the ratio of the Gross enrolment ratio (%) of Tertiary schools in Cote d'Ivoire to that in Cyprus?
Give a very brief answer. 0.52. What is the ratio of the Gross enrolment ratio (%) of Pre-primary schools in Cote d'Ivoire to that in Czech Republic?
Make the answer very short. 0.03. What is the ratio of the Gross enrolment ratio (%) of Primary schools in Cote d'Ivoire to that in Czech Republic?
Make the answer very short. 0.61. What is the ratio of the Gross enrolment ratio (%) in Secondary schools in Cote d'Ivoire to that in Czech Republic?
Your answer should be very brief. 4.33. What is the ratio of the Gross enrolment ratio (%) in Tertiary schools in Cote d'Ivoire to that in Czech Republic?
Make the answer very short. 0.02. What is the ratio of the Gross enrolment ratio (%) in Pre-primary schools in Croatia to that in Cuba?
Provide a succinct answer. 0.43. What is the ratio of the Gross enrolment ratio (%) of Primary schools in Croatia to that in Cuba?
Offer a terse response. 0.92. What is the ratio of the Gross enrolment ratio (%) of Tertiary schools in Croatia to that in Cuba?
Offer a terse response. 1.87. What is the ratio of the Gross enrolment ratio (%) in Pre-primary schools in Croatia to that in Cyprus?
Make the answer very short. 0.78. What is the ratio of the Gross enrolment ratio (%) of Primary schools in Croatia to that in Cyprus?
Your response must be concise. 0.85. What is the ratio of the Gross enrolment ratio (%) in Secondary schools in Croatia to that in Cyprus?
Give a very brief answer. 0.78. What is the ratio of the Gross enrolment ratio (%) in Tertiary schools in Croatia to that in Cyprus?
Your response must be concise. 16.53. What is the ratio of the Gross enrolment ratio (%) of Pre-primary schools in Croatia to that in Czech Republic?
Give a very brief answer. 0.47. What is the ratio of the Gross enrolment ratio (%) in Primary schools in Croatia to that in Czech Republic?
Provide a succinct answer. 0.71. What is the ratio of the Gross enrolment ratio (%) of Secondary schools in Croatia to that in Czech Republic?
Give a very brief answer. 4.69. What is the ratio of the Gross enrolment ratio (%) of Tertiary schools in Croatia to that in Czech Republic?
Ensure brevity in your answer.  0.75. What is the ratio of the Gross enrolment ratio (%) in Pre-primary schools in Cuba to that in Cyprus?
Offer a very short reply. 1.79. What is the ratio of the Gross enrolment ratio (%) of Primary schools in Cuba to that in Cyprus?
Provide a succinct answer. 0.92. What is the ratio of the Gross enrolment ratio (%) of Secondary schools in Cuba to that in Cyprus?
Your answer should be very brief. 0.77. What is the ratio of the Gross enrolment ratio (%) of Tertiary schools in Cuba to that in Cyprus?
Ensure brevity in your answer.  8.82. What is the ratio of the Gross enrolment ratio (%) in Pre-primary schools in Cuba to that in Czech Republic?
Make the answer very short. 1.09. What is the ratio of the Gross enrolment ratio (%) of Primary schools in Cuba to that in Czech Republic?
Provide a succinct answer. 0.77. What is the ratio of the Gross enrolment ratio (%) of Secondary schools in Cuba to that in Czech Republic?
Ensure brevity in your answer.  4.63. What is the ratio of the Gross enrolment ratio (%) of Tertiary schools in Cuba to that in Czech Republic?
Give a very brief answer. 0.4. What is the ratio of the Gross enrolment ratio (%) of Pre-primary schools in Cyprus to that in Czech Republic?
Ensure brevity in your answer.  0.61. What is the ratio of the Gross enrolment ratio (%) in Primary schools in Cyprus to that in Czech Republic?
Provide a short and direct response. 0.84. What is the ratio of the Gross enrolment ratio (%) of Secondary schools in Cyprus to that in Czech Republic?
Give a very brief answer. 6.03. What is the ratio of the Gross enrolment ratio (%) in Tertiary schools in Cyprus to that in Czech Republic?
Offer a very short reply. 0.05. What is the difference between the highest and the second highest Gross enrolment ratio (%) of Pre-primary schools?
Your response must be concise. 8.34. What is the difference between the highest and the second highest Gross enrolment ratio (%) in Primary schools?
Make the answer very short. 22.63. What is the difference between the highest and the second highest Gross enrolment ratio (%) in Secondary schools?
Keep it short and to the point. 27.46. What is the difference between the highest and the second highest Gross enrolment ratio (%) in Tertiary schools?
Provide a succinct answer. 5.79. What is the difference between the highest and the lowest Gross enrolment ratio (%) of Pre-primary schools?
Offer a terse response. 103.19. What is the difference between the highest and the lowest Gross enrolment ratio (%) of Primary schools?
Provide a succinct answer. 55.98. What is the difference between the highest and the lowest Gross enrolment ratio (%) in Secondary schools?
Offer a very short reply. 102.93. What is the difference between the highest and the lowest Gross enrolment ratio (%) in Tertiary schools?
Offer a terse response. 52.24. 